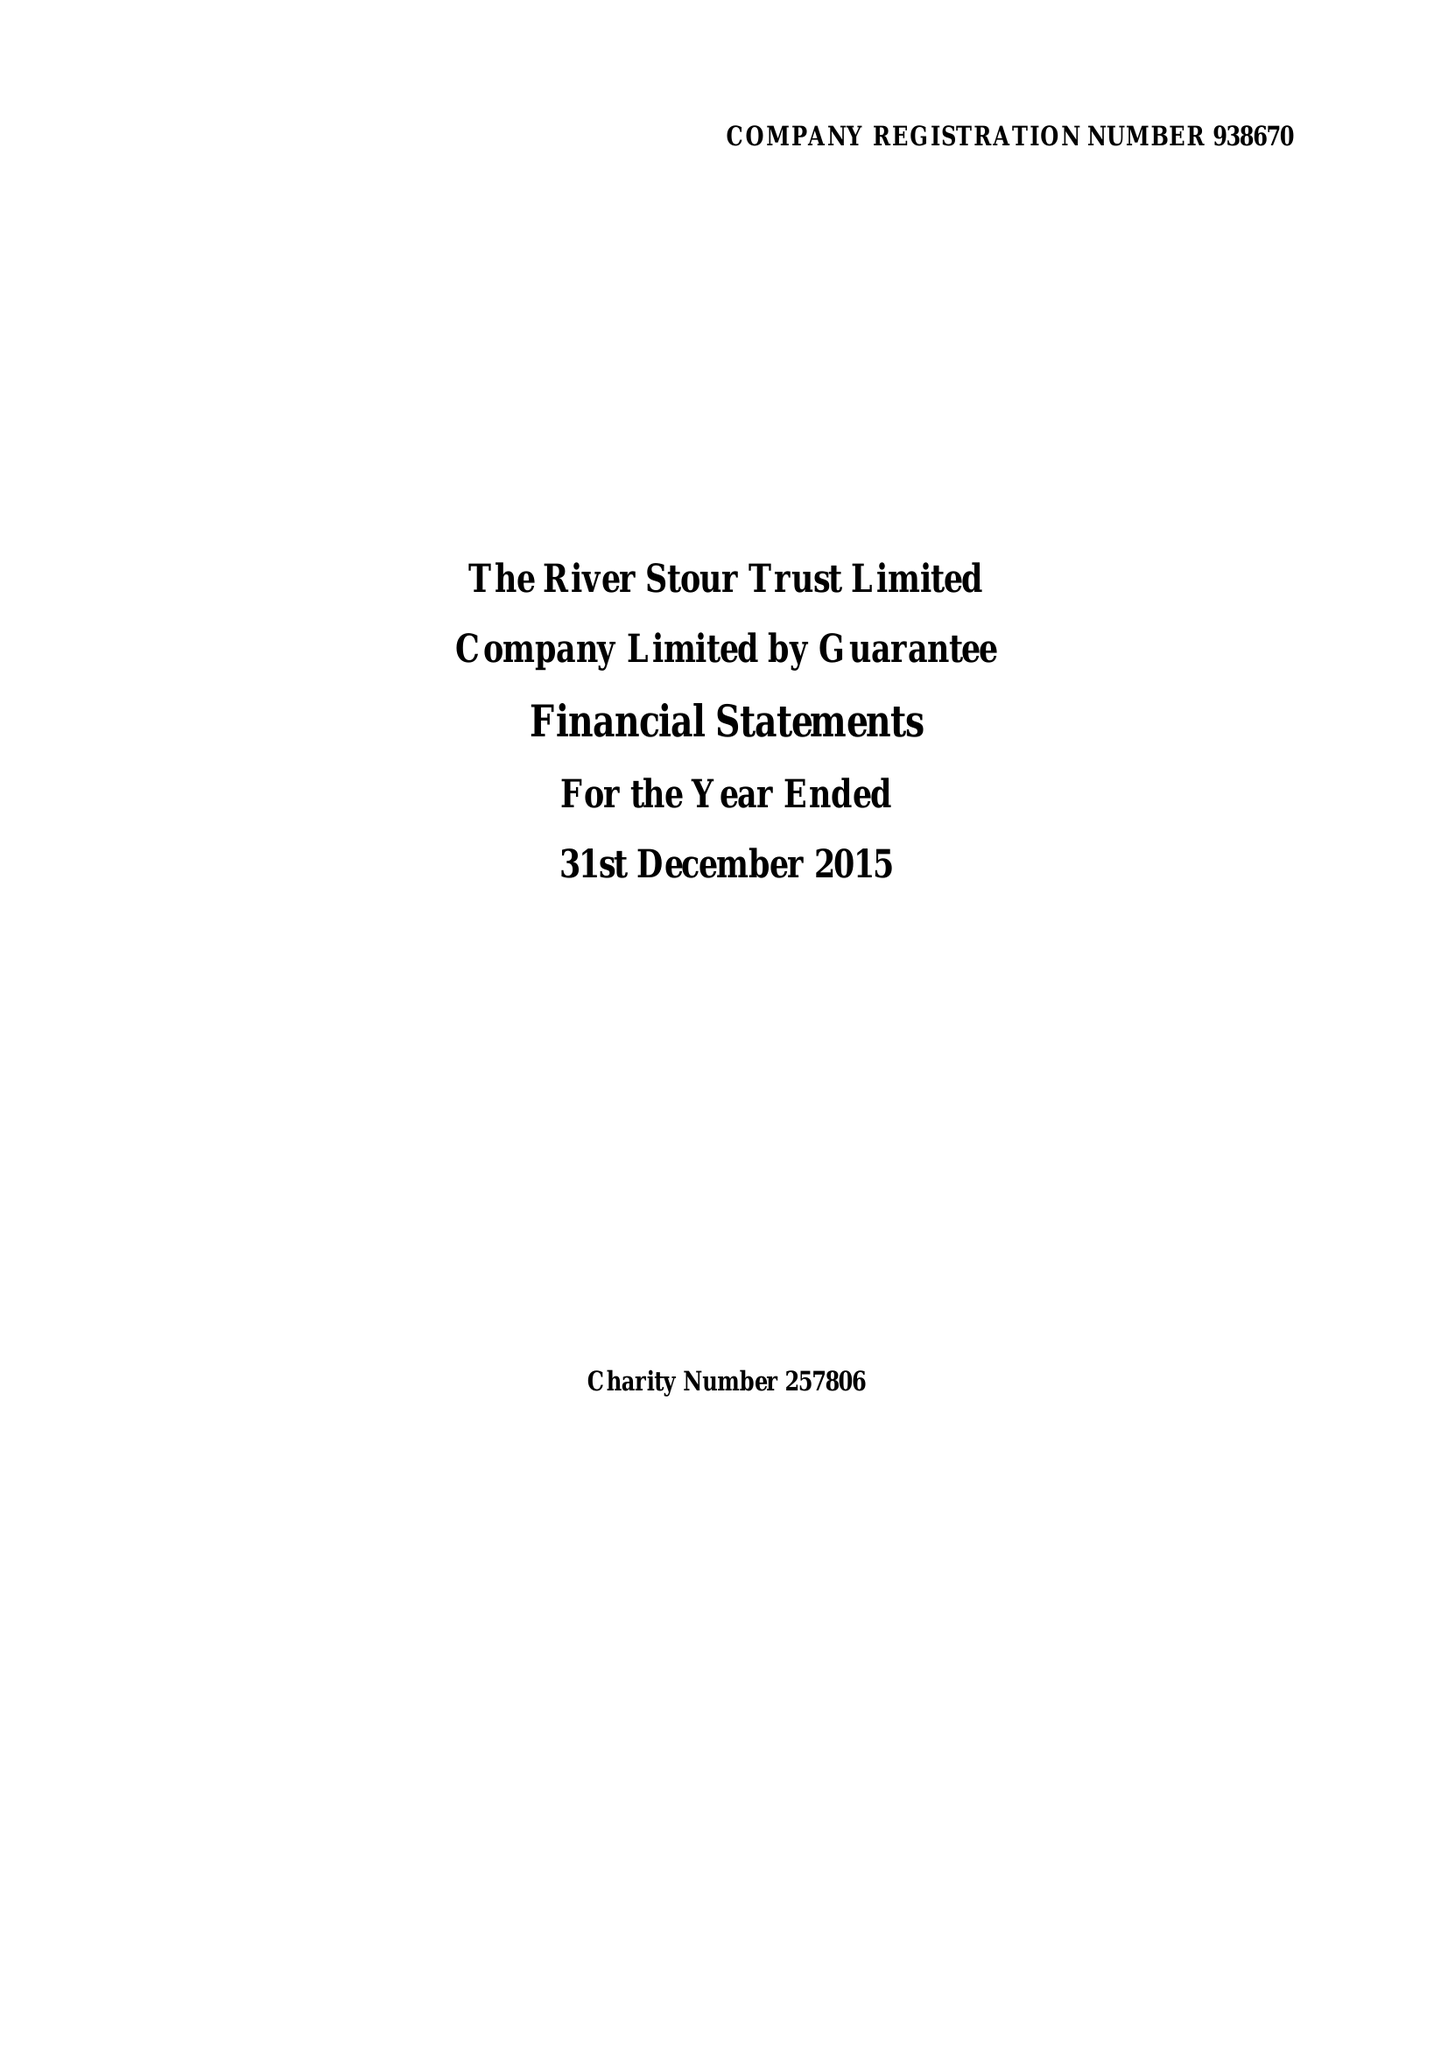What is the value for the income_annually_in_british_pounds?
Answer the question using a single word or phrase. 106746.00 